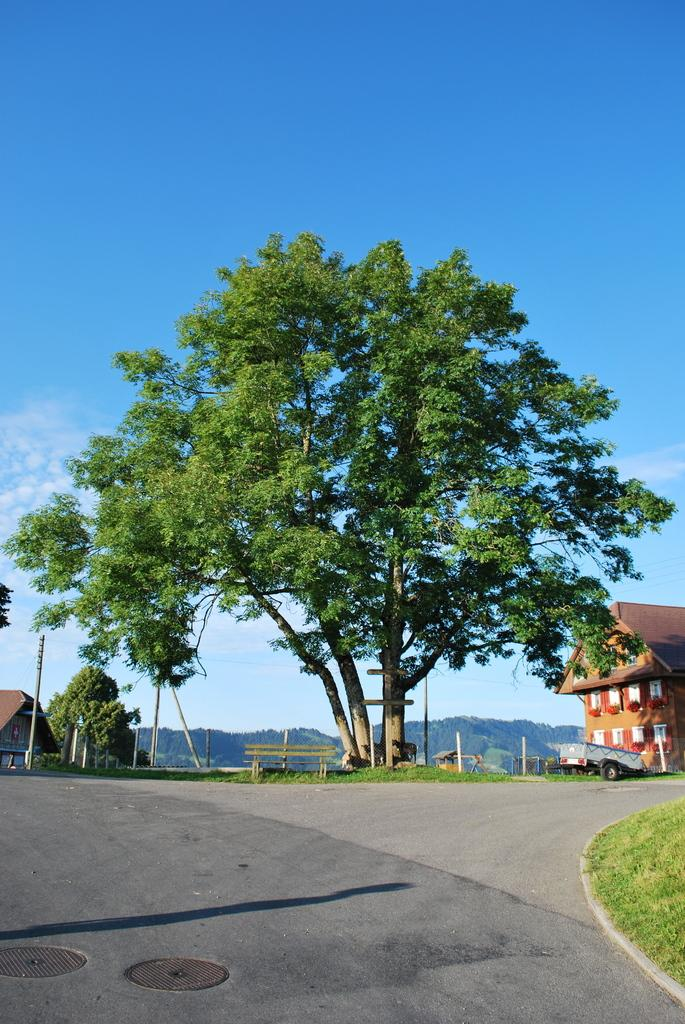What is the main feature of the image? There is a road in the image. What can be seen beside the road? There is a grassy surface beside the road. What is visible in the background of the image? Buildings, trees, poles, a bench, mountains, and the sky are visible in the background of the image. What type of powder is being used to create the shade on the bench in the image? There is no powder or shade on the bench in the image. The bench is simply visible in the background. 